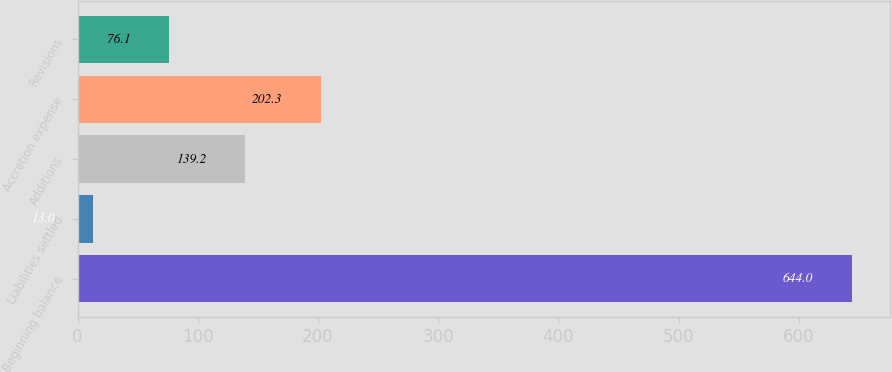<chart> <loc_0><loc_0><loc_500><loc_500><bar_chart><fcel>Beginning balance<fcel>Liabilities settled<fcel>Additions<fcel>Accretion expense<fcel>Revisions<nl><fcel>644<fcel>13<fcel>139.2<fcel>202.3<fcel>76.1<nl></chart> 